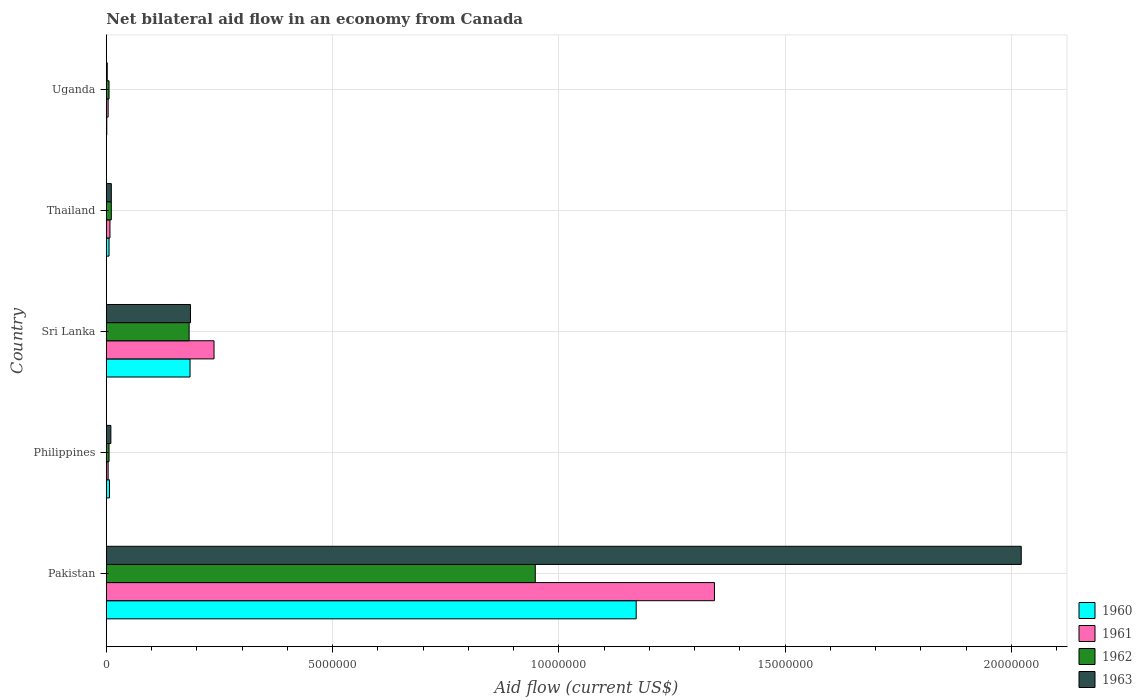How many different coloured bars are there?
Make the answer very short. 4. Are the number of bars per tick equal to the number of legend labels?
Ensure brevity in your answer.  Yes. Are the number of bars on each tick of the Y-axis equal?
Make the answer very short. Yes. How many bars are there on the 5th tick from the top?
Offer a terse response. 4. What is the label of the 5th group of bars from the top?
Ensure brevity in your answer.  Pakistan. Across all countries, what is the maximum net bilateral aid flow in 1962?
Your answer should be very brief. 9.48e+06. In which country was the net bilateral aid flow in 1961 maximum?
Your answer should be compact. Pakistan. In which country was the net bilateral aid flow in 1961 minimum?
Ensure brevity in your answer.  Philippines. What is the total net bilateral aid flow in 1963 in the graph?
Your answer should be very brief. 2.23e+07. What is the difference between the net bilateral aid flow in 1961 in Philippines and that in Sri Lanka?
Offer a very short reply. -2.34e+06. What is the difference between the net bilateral aid flow in 1962 in Uganda and the net bilateral aid flow in 1963 in Sri Lanka?
Offer a terse response. -1.80e+06. What is the average net bilateral aid flow in 1960 per country?
Provide a succinct answer. 2.74e+06. In how many countries, is the net bilateral aid flow in 1960 greater than 10000000 US$?
Give a very brief answer. 1. Is the net bilateral aid flow in 1962 in Philippines less than that in Thailand?
Give a very brief answer. Yes. Is the difference between the net bilateral aid flow in 1961 in Pakistan and Uganda greater than the difference between the net bilateral aid flow in 1962 in Pakistan and Uganda?
Make the answer very short. Yes. What is the difference between the highest and the second highest net bilateral aid flow in 1961?
Provide a short and direct response. 1.11e+07. What is the difference between the highest and the lowest net bilateral aid flow in 1963?
Make the answer very short. 2.02e+07. In how many countries, is the net bilateral aid flow in 1961 greater than the average net bilateral aid flow in 1961 taken over all countries?
Keep it short and to the point. 1. Is the sum of the net bilateral aid flow in 1961 in Philippines and Uganda greater than the maximum net bilateral aid flow in 1963 across all countries?
Ensure brevity in your answer.  No. Is it the case that in every country, the sum of the net bilateral aid flow in 1961 and net bilateral aid flow in 1960 is greater than the sum of net bilateral aid flow in 1963 and net bilateral aid flow in 1962?
Give a very brief answer. No. What does the 1st bar from the bottom in Philippines represents?
Make the answer very short. 1960. Is it the case that in every country, the sum of the net bilateral aid flow in 1962 and net bilateral aid flow in 1960 is greater than the net bilateral aid flow in 1963?
Your answer should be compact. Yes. What is the difference between two consecutive major ticks on the X-axis?
Give a very brief answer. 5.00e+06. Does the graph contain any zero values?
Offer a very short reply. No. Does the graph contain grids?
Make the answer very short. Yes. Where does the legend appear in the graph?
Offer a terse response. Bottom right. How many legend labels are there?
Your response must be concise. 4. What is the title of the graph?
Provide a succinct answer. Net bilateral aid flow in an economy from Canada. What is the label or title of the X-axis?
Keep it short and to the point. Aid flow (current US$). What is the label or title of the Y-axis?
Make the answer very short. Country. What is the Aid flow (current US$) in 1960 in Pakistan?
Offer a very short reply. 1.17e+07. What is the Aid flow (current US$) in 1961 in Pakistan?
Your answer should be very brief. 1.34e+07. What is the Aid flow (current US$) of 1962 in Pakistan?
Offer a terse response. 9.48e+06. What is the Aid flow (current US$) in 1963 in Pakistan?
Give a very brief answer. 2.02e+07. What is the Aid flow (current US$) in 1963 in Philippines?
Your answer should be very brief. 1.00e+05. What is the Aid flow (current US$) of 1960 in Sri Lanka?
Offer a terse response. 1.85e+06. What is the Aid flow (current US$) of 1961 in Sri Lanka?
Your response must be concise. 2.38e+06. What is the Aid flow (current US$) in 1962 in Sri Lanka?
Your answer should be compact. 1.83e+06. What is the Aid flow (current US$) of 1963 in Sri Lanka?
Ensure brevity in your answer.  1.86e+06. What is the Aid flow (current US$) in 1963 in Thailand?
Keep it short and to the point. 1.10e+05. What is the Aid flow (current US$) in 1962 in Uganda?
Your answer should be compact. 6.00e+04. What is the Aid flow (current US$) in 1963 in Uganda?
Your answer should be compact. 2.00e+04. Across all countries, what is the maximum Aid flow (current US$) of 1960?
Provide a short and direct response. 1.17e+07. Across all countries, what is the maximum Aid flow (current US$) of 1961?
Your answer should be very brief. 1.34e+07. Across all countries, what is the maximum Aid flow (current US$) in 1962?
Ensure brevity in your answer.  9.48e+06. Across all countries, what is the maximum Aid flow (current US$) in 1963?
Provide a succinct answer. 2.02e+07. Across all countries, what is the minimum Aid flow (current US$) of 1960?
Provide a succinct answer. 10000. Across all countries, what is the minimum Aid flow (current US$) of 1961?
Your answer should be compact. 4.00e+04. What is the total Aid flow (current US$) of 1960 in the graph?
Keep it short and to the point. 1.37e+07. What is the total Aid flow (current US$) of 1961 in the graph?
Provide a short and direct response. 1.60e+07. What is the total Aid flow (current US$) in 1962 in the graph?
Offer a terse response. 1.15e+07. What is the total Aid flow (current US$) of 1963 in the graph?
Your answer should be compact. 2.23e+07. What is the difference between the Aid flow (current US$) of 1960 in Pakistan and that in Philippines?
Your response must be concise. 1.16e+07. What is the difference between the Aid flow (current US$) of 1961 in Pakistan and that in Philippines?
Offer a very short reply. 1.34e+07. What is the difference between the Aid flow (current US$) in 1962 in Pakistan and that in Philippines?
Make the answer very short. 9.42e+06. What is the difference between the Aid flow (current US$) of 1963 in Pakistan and that in Philippines?
Ensure brevity in your answer.  2.01e+07. What is the difference between the Aid flow (current US$) of 1960 in Pakistan and that in Sri Lanka?
Your answer should be very brief. 9.86e+06. What is the difference between the Aid flow (current US$) in 1961 in Pakistan and that in Sri Lanka?
Offer a very short reply. 1.11e+07. What is the difference between the Aid flow (current US$) in 1962 in Pakistan and that in Sri Lanka?
Provide a short and direct response. 7.65e+06. What is the difference between the Aid flow (current US$) in 1963 in Pakistan and that in Sri Lanka?
Provide a short and direct response. 1.84e+07. What is the difference between the Aid flow (current US$) of 1960 in Pakistan and that in Thailand?
Your response must be concise. 1.16e+07. What is the difference between the Aid flow (current US$) of 1961 in Pakistan and that in Thailand?
Your answer should be compact. 1.34e+07. What is the difference between the Aid flow (current US$) of 1962 in Pakistan and that in Thailand?
Keep it short and to the point. 9.37e+06. What is the difference between the Aid flow (current US$) of 1963 in Pakistan and that in Thailand?
Offer a terse response. 2.01e+07. What is the difference between the Aid flow (current US$) in 1960 in Pakistan and that in Uganda?
Offer a very short reply. 1.17e+07. What is the difference between the Aid flow (current US$) of 1961 in Pakistan and that in Uganda?
Provide a succinct answer. 1.34e+07. What is the difference between the Aid flow (current US$) in 1962 in Pakistan and that in Uganda?
Provide a succinct answer. 9.42e+06. What is the difference between the Aid flow (current US$) of 1963 in Pakistan and that in Uganda?
Provide a short and direct response. 2.02e+07. What is the difference between the Aid flow (current US$) in 1960 in Philippines and that in Sri Lanka?
Make the answer very short. -1.78e+06. What is the difference between the Aid flow (current US$) in 1961 in Philippines and that in Sri Lanka?
Ensure brevity in your answer.  -2.34e+06. What is the difference between the Aid flow (current US$) in 1962 in Philippines and that in Sri Lanka?
Provide a short and direct response. -1.77e+06. What is the difference between the Aid flow (current US$) in 1963 in Philippines and that in Sri Lanka?
Your response must be concise. -1.76e+06. What is the difference between the Aid flow (current US$) in 1960 in Philippines and that in Thailand?
Your response must be concise. 10000. What is the difference between the Aid flow (current US$) of 1962 in Philippines and that in Uganda?
Keep it short and to the point. 0. What is the difference between the Aid flow (current US$) of 1963 in Philippines and that in Uganda?
Give a very brief answer. 8.00e+04. What is the difference between the Aid flow (current US$) of 1960 in Sri Lanka and that in Thailand?
Offer a terse response. 1.79e+06. What is the difference between the Aid flow (current US$) in 1961 in Sri Lanka and that in Thailand?
Your response must be concise. 2.30e+06. What is the difference between the Aid flow (current US$) in 1962 in Sri Lanka and that in Thailand?
Offer a terse response. 1.72e+06. What is the difference between the Aid flow (current US$) of 1963 in Sri Lanka and that in Thailand?
Give a very brief answer. 1.75e+06. What is the difference between the Aid flow (current US$) in 1960 in Sri Lanka and that in Uganda?
Ensure brevity in your answer.  1.84e+06. What is the difference between the Aid flow (current US$) of 1961 in Sri Lanka and that in Uganda?
Your answer should be compact. 2.34e+06. What is the difference between the Aid flow (current US$) of 1962 in Sri Lanka and that in Uganda?
Your response must be concise. 1.77e+06. What is the difference between the Aid flow (current US$) in 1963 in Sri Lanka and that in Uganda?
Keep it short and to the point. 1.84e+06. What is the difference between the Aid flow (current US$) of 1960 in Pakistan and the Aid flow (current US$) of 1961 in Philippines?
Your answer should be very brief. 1.17e+07. What is the difference between the Aid flow (current US$) in 1960 in Pakistan and the Aid flow (current US$) in 1962 in Philippines?
Your response must be concise. 1.16e+07. What is the difference between the Aid flow (current US$) in 1960 in Pakistan and the Aid flow (current US$) in 1963 in Philippines?
Make the answer very short. 1.16e+07. What is the difference between the Aid flow (current US$) in 1961 in Pakistan and the Aid flow (current US$) in 1962 in Philippines?
Your response must be concise. 1.34e+07. What is the difference between the Aid flow (current US$) of 1961 in Pakistan and the Aid flow (current US$) of 1963 in Philippines?
Give a very brief answer. 1.33e+07. What is the difference between the Aid flow (current US$) of 1962 in Pakistan and the Aid flow (current US$) of 1963 in Philippines?
Give a very brief answer. 9.38e+06. What is the difference between the Aid flow (current US$) in 1960 in Pakistan and the Aid flow (current US$) in 1961 in Sri Lanka?
Your answer should be compact. 9.33e+06. What is the difference between the Aid flow (current US$) in 1960 in Pakistan and the Aid flow (current US$) in 1962 in Sri Lanka?
Provide a short and direct response. 9.88e+06. What is the difference between the Aid flow (current US$) in 1960 in Pakistan and the Aid flow (current US$) in 1963 in Sri Lanka?
Give a very brief answer. 9.85e+06. What is the difference between the Aid flow (current US$) of 1961 in Pakistan and the Aid flow (current US$) of 1962 in Sri Lanka?
Offer a very short reply. 1.16e+07. What is the difference between the Aid flow (current US$) of 1961 in Pakistan and the Aid flow (current US$) of 1963 in Sri Lanka?
Offer a very short reply. 1.16e+07. What is the difference between the Aid flow (current US$) in 1962 in Pakistan and the Aid flow (current US$) in 1963 in Sri Lanka?
Provide a short and direct response. 7.62e+06. What is the difference between the Aid flow (current US$) of 1960 in Pakistan and the Aid flow (current US$) of 1961 in Thailand?
Your answer should be compact. 1.16e+07. What is the difference between the Aid flow (current US$) of 1960 in Pakistan and the Aid flow (current US$) of 1962 in Thailand?
Keep it short and to the point. 1.16e+07. What is the difference between the Aid flow (current US$) of 1960 in Pakistan and the Aid flow (current US$) of 1963 in Thailand?
Give a very brief answer. 1.16e+07. What is the difference between the Aid flow (current US$) in 1961 in Pakistan and the Aid flow (current US$) in 1962 in Thailand?
Your answer should be very brief. 1.33e+07. What is the difference between the Aid flow (current US$) in 1961 in Pakistan and the Aid flow (current US$) in 1963 in Thailand?
Offer a terse response. 1.33e+07. What is the difference between the Aid flow (current US$) of 1962 in Pakistan and the Aid flow (current US$) of 1963 in Thailand?
Provide a succinct answer. 9.37e+06. What is the difference between the Aid flow (current US$) in 1960 in Pakistan and the Aid flow (current US$) in 1961 in Uganda?
Provide a short and direct response. 1.17e+07. What is the difference between the Aid flow (current US$) of 1960 in Pakistan and the Aid flow (current US$) of 1962 in Uganda?
Your response must be concise. 1.16e+07. What is the difference between the Aid flow (current US$) in 1960 in Pakistan and the Aid flow (current US$) in 1963 in Uganda?
Your answer should be compact. 1.17e+07. What is the difference between the Aid flow (current US$) of 1961 in Pakistan and the Aid flow (current US$) of 1962 in Uganda?
Your answer should be very brief. 1.34e+07. What is the difference between the Aid flow (current US$) in 1961 in Pakistan and the Aid flow (current US$) in 1963 in Uganda?
Provide a succinct answer. 1.34e+07. What is the difference between the Aid flow (current US$) in 1962 in Pakistan and the Aid flow (current US$) in 1963 in Uganda?
Your response must be concise. 9.46e+06. What is the difference between the Aid flow (current US$) in 1960 in Philippines and the Aid flow (current US$) in 1961 in Sri Lanka?
Provide a short and direct response. -2.31e+06. What is the difference between the Aid flow (current US$) in 1960 in Philippines and the Aid flow (current US$) in 1962 in Sri Lanka?
Your response must be concise. -1.76e+06. What is the difference between the Aid flow (current US$) of 1960 in Philippines and the Aid flow (current US$) of 1963 in Sri Lanka?
Keep it short and to the point. -1.79e+06. What is the difference between the Aid flow (current US$) of 1961 in Philippines and the Aid flow (current US$) of 1962 in Sri Lanka?
Make the answer very short. -1.79e+06. What is the difference between the Aid flow (current US$) of 1961 in Philippines and the Aid flow (current US$) of 1963 in Sri Lanka?
Give a very brief answer. -1.82e+06. What is the difference between the Aid flow (current US$) in 1962 in Philippines and the Aid flow (current US$) in 1963 in Sri Lanka?
Your answer should be very brief. -1.80e+06. What is the difference between the Aid flow (current US$) of 1960 in Philippines and the Aid flow (current US$) of 1961 in Thailand?
Your response must be concise. -10000. What is the difference between the Aid flow (current US$) of 1960 in Philippines and the Aid flow (current US$) of 1962 in Thailand?
Your answer should be compact. -4.00e+04. What is the difference between the Aid flow (current US$) of 1960 in Philippines and the Aid flow (current US$) of 1963 in Thailand?
Keep it short and to the point. -4.00e+04. What is the difference between the Aid flow (current US$) in 1961 in Philippines and the Aid flow (current US$) in 1963 in Thailand?
Offer a very short reply. -7.00e+04. What is the difference between the Aid flow (current US$) of 1961 in Philippines and the Aid flow (current US$) of 1962 in Uganda?
Make the answer very short. -2.00e+04. What is the difference between the Aid flow (current US$) of 1961 in Philippines and the Aid flow (current US$) of 1963 in Uganda?
Provide a succinct answer. 2.00e+04. What is the difference between the Aid flow (current US$) in 1960 in Sri Lanka and the Aid flow (current US$) in 1961 in Thailand?
Ensure brevity in your answer.  1.77e+06. What is the difference between the Aid flow (current US$) of 1960 in Sri Lanka and the Aid flow (current US$) of 1962 in Thailand?
Give a very brief answer. 1.74e+06. What is the difference between the Aid flow (current US$) in 1960 in Sri Lanka and the Aid flow (current US$) in 1963 in Thailand?
Offer a terse response. 1.74e+06. What is the difference between the Aid flow (current US$) of 1961 in Sri Lanka and the Aid flow (current US$) of 1962 in Thailand?
Give a very brief answer. 2.27e+06. What is the difference between the Aid flow (current US$) in 1961 in Sri Lanka and the Aid flow (current US$) in 1963 in Thailand?
Provide a succinct answer. 2.27e+06. What is the difference between the Aid flow (current US$) in 1962 in Sri Lanka and the Aid flow (current US$) in 1963 in Thailand?
Your response must be concise. 1.72e+06. What is the difference between the Aid flow (current US$) of 1960 in Sri Lanka and the Aid flow (current US$) of 1961 in Uganda?
Provide a short and direct response. 1.81e+06. What is the difference between the Aid flow (current US$) of 1960 in Sri Lanka and the Aid flow (current US$) of 1962 in Uganda?
Your answer should be very brief. 1.79e+06. What is the difference between the Aid flow (current US$) in 1960 in Sri Lanka and the Aid flow (current US$) in 1963 in Uganda?
Your response must be concise. 1.83e+06. What is the difference between the Aid flow (current US$) of 1961 in Sri Lanka and the Aid flow (current US$) of 1962 in Uganda?
Your answer should be compact. 2.32e+06. What is the difference between the Aid flow (current US$) in 1961 in Sri Lanka and the Aid flow (current US$) in 1963 in Uganda?
Provide a short and direct response. 2.36e+06. What is the difference between the Aid flow (current US$) of 1962 in Sri Lanka and the Aid flow (current US$) of 1963 in Uganda?
Make the answer very short. 1.81e+06. What is the difference between the Aid flow (current US$) in 1960 in Thailand and the Aid flow (current US$) in 1961 in Uganda?
Provide a succinct answer. 2.00e+04. What is the difference between the Aid flow (current US$) of 1960 in Thailand and the Aid flow (current US$) of 1962 in Uganda?
Offer a terse response. 0. What is the difference between the Aid flow (current US$) of 1961 in Thailand and the Aid flow (current US$) of 1963 in Uganda?
Keep it short and to the point. 6.00e+04. What is the average Aid flow (current US$) in 1960 per country?
Offer a very short reply. 2.74e+06. What is the average Aid flow (current US$) of 1961 per country?
Give a very brief answer. 3.20e+06. What is the average Aid flow (current US$) of 1962 per country?
Ensure brevity in your answer.  2.31e+06. What is the average Aid flow (current US$) in 1963 per country?
Your answer should be very brief. 4.46e+06. What is the difference between the Aid flow (current US$) in 1960 and Aid flow (current US$) in 1961 in Pakistan?
Give a very brief answer. -1.73e+06. What is the difference between the Aid flow (current US$) in 1960 and Aid flow (current US$) in 1962 in Pakistan?
Offer a terse response. 2.23e+06. What is the difference between the Aid flow (current US$) of 1960 and Aid flow (current US$) of 1963 in Pakistan?
Give a very brief answer. -8.51e+06. What is the difference between the Aid flow (current US$) in 1961 and Aid flow (current US$) in 1962 in Pakistan?
Your response must be concise. 3.96e+06. What is the difference between the Aid flow (current US$) of 1961 and Aid flow (current US$) of 1963 in Pakistan?
Make the answer very short. -6.78e+06. What is the difference between the Aid flow (current US$) of 1962 and Aid flow (current US$) of 1963 in Pakistan?
Provide a short and direct response. -1.07e+07. What is the difference between the Aid flow (current US$) of 1960 and Aid flow (current US$) of 1962 in Philippines?
Offer a terse response. 10000. What is the difference between the Aid flow (current US$) of 1960 and Aid flow (current US$) of 1963 in Philippines?
Keep it short and to the point. -3.00e+04. What is the difference between the Aid flow (current US$) in 1961 and Aid flow (current US$) in 1963 in Philippines?
Your response must be concise. -6.00e+04. What is the difference between the Aid flow (current US$) in 1962 and Aid flow (current US$) in 1963 in Philippines?
Your answer should be compact. -4.00e+04. What is the difference between the Aid flow (current US$) in 1960 and Aid flow (current US$) in 1961 in Sri Lanka?
Your response must be concise. -5.30e+05. What is the difference between the Aid flow (current US$) of 1961 and Aid flow (current US$) of 1962 in Sri Lanka?
Provide a short and direct response. 5.50e+05. What is the difference between the Aid flow (current US$) in 1961 and Aid flow (current US$) in 1963 in Sri Lanka?
Give a very brief answer. 5.20e+05. What is the difference between the Aid flow (current US$) in 1962 and Aid flow (current US$) in 1963 in Sri Lanka?
Offer a very short reply. -3.00e+04. What is the difference between the Aid flow (current US$) of 1961 and Aid flow (current US$) of 1962 in Thailand?
Your answer should be very brief. -3.00e+04. What is the difference between the Aid flow (current US$) of 1961 and Aid flow (current US$) of 1963 in Thailand?
Provide a short and direct response. -3.00e+04. What is the difference between the Aid flow (current US$) in 1960 and Aid flow (current US$) in 1962 in Uganda?
Your response must be concise. -5.00e+04. What is the difference between the Aid flow (current US$) of 1960 and Aid flow (current US$) of 1963 in Uganda?
Your answer should be very brief. -10000. What is the difference between the Aid flow (current US$) in 1961 and Aid flow (current US$) in 1962 in Uganda?
Make the answer very short. -2.00e+04. What is the difference between the Aid flow (current US$) of 1961 and Aid flow (current US$) of 1963 in Uganda?
Offer a very short reply. 2.00e+04. What is the ratio of the Aid flow (current US$) of 1960 in Pakistan to that in Philippines?
Ensure brevity in your answer.  167.29. What is the ratio of the Aid flow (current US$) in 1961 in Pakistan to that in Philippines?
Make the answer very short. 336. What is the ratio of the Aid flow (current US$) in 1962 in Pakistan to that in Philippines?
Give a very brief answer. 158. What is the ratio of the Aid flow (current US$) in 1963 in Pakistan to that in Philippines?
Give a very brief answer. 202.2. What is the ratio of the Aid flow (current US$) of 1960 in Pakistan to that in Sri Lanka?
Make the answer very short. 6.33. What is the ratio of the Aid flow (current US$) in 1961 in Pakistan to that in Sri Lanka?
Offer a terse response. 5.65. What is the ratio of the Aid flow (current US$) of 1962 in Pakistan to that in Sri Lanka?
Ensure brevity in your answer.  5.18. What is the ratio of the Aid flow (current US$) in 1963 in Pakistan to that in Sri Lanka?
Offer a terse response. 10.87. What is the ratio of the Aid flow (current US$) in 1960 in Pakistan to that in Thailand?
Give a very brief answer. 195.17. What is the ratio of the Aid flow (current US$) of 1961 in Pakistan to that in Thailand?
Offer a terse response. 168. What is the ratio of the Aid flow (current US$) in 1962 in Pakistan to that in Thailand?
Ensure brevity in your answer.  86.18. What is the ratio of the Aid flow (current US$) in 1963 in Pakistan to that in Thailand?
Your answer should be compact. 183.82. What is the ratio of the Aid flow (current US$) of 1960 in Pakistan to that in Uganda?
Give a very brief answer. 1171. What is the ratio of the Aid flow (current US$) in 1961 in Pakistan to that in Uganda?
Your response must be concise. 336. What is the ratio of the Aid flow (current US$) of 1962 in Pakistan to that in Uganda?
Offer a terse response. 158. What is the ratio of the Aid flow (current US$) in 1963 in Pakistan to that in Uganda?
Keep it short and to the point. 1011. What is the ratio of the Aid flow (current US$) of 1960 in Philippines to that in Sri Lanka?
Ensure brevity in your answer.  0.04. What is the ratio of the Aid flow (current US$) in 1961 in Philippines to that in Sri Lanka?
Provide a succinct answer. 0.02. What is the ratio of the Aid flow (current US$) of 1962 in Philippines to that in Sri Lanka?
Make the answer very short. 0.03. What is the ratio of the Aid flow (current US$) of 1963 in Philippines to that in Sri Lanka?
Your answer should be very brief. 0.05. What is the ratio of the Aid flow (current US$) of 1961 in Philippines to that in Thailand?
Offer a very short reply. 0.5. What is the ratio of the Aid flow (current US$) of 1962 in Philippines to that in Thailand?
Give a very brief answer. 0.55. What is the ratio of the Aid flow (current US$) in 1963 in Philippines to that in Thailand?
Offer a very short reply. 0.91. What is the ratio of the Aid flow (current US$) in 1961 in Philippines to that in Uganda?
Offer a very short reply. 1. What is the ratio of the Aid flow (current US$) in 1963 in Philippines to that in Uganda?
Give a very brief answer. 5. What is the ratio of the Aid flow (current US$) of 1960 in Sri Lanka to that in Thailand?
Keep it short and to the point. 30.83. What is the ratio of the Aid flow (current US$) in 1961 in Sri Lanka to that in Thailand?
Give a very brief answer. 29.75. What is the ratio of the Aid flow (current US$) of 1962 in Sri Lanka to that in Thailand?
Offer a very short reply. 16.64. What is the ratio of the Aid flow (current US$) in 1963 in Sri Lanka to that in Thailand?
Your response must be concise. 16.91. What is the ratio of the Aid flow (current US$) in 1960 in Sri Lanka to that in Uganda?
Provide a succinct answer. 185. What is the ratio of the Aid flow (current US$) of 1961 in Sri Lanka to that in Uganda?
Your response must be concise. 59.5. What is the ratio of the Aid flow (current US$) of 1962 in Sri Lanka to that in Uganda?
Make the answer very short. 30.5. What is the ratio of the Aid flow (current US$) in 1963 in Sri Lanka to that in Uganda?
Offer a very short reply. 93. What is the ratio of the Aid flow (current US$) of 1961 in Thailand to that in Uganda?
Give a very brief answer. 2. What is the ratio of the Aid flow (current US$) in 1962 in Thailand to that in Uganda?
Your answer should be compact. 1.83. What is the difference between the highest and the second highest Aid flow (current US$) in 1960?
Make the answer very short. 9.86e+06. What is the difference between the highest and the second highest Aid flow (current US$) in 1961?
Your response must be concise. 1.11e+07. What is the difference between the highest and the second highest Aid flow (current US$) in 1962?
Your answer should be very brief. 7.65e+06. What is the difference between the highest and the second highest Aid flow (current US$) in 1963?
Provide a succinct answer. 1.84e+07. What is the difference between the highest and the lowest Aid flow (current US$) in 1960?
Keep it short and to the point. 1.17e+07. What is the difference between the highest and the lowest Aid flow (current US$) in 1961?
Provide a succinct answer. 1.34e+07. What is the difference between the highest and the lowest Aid flow (current US$) of 1962?
Your answer should be compact. 9.42e+06. What is the difference between the highest and the lowest Aid flow (current US$) in 1963?
Your response must be concise. 2.02e+07. 